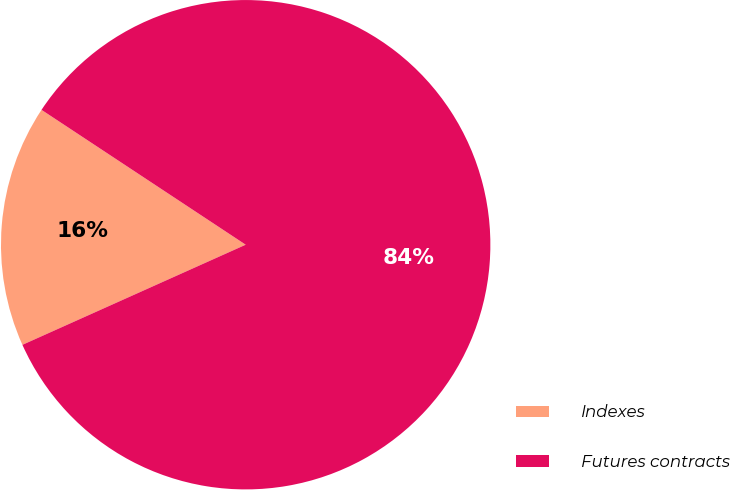Convert chart to OTSL. <chart><loc_0><loc_0><loc_500><loc_500><pie_chart><fcel>Indexes<fcel>Futures contracts<nl><fcel>16.0%<fcel>84.0%<nl></chart> 